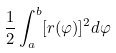<formula> <loc_0><loc_0><loc_500><loc_500>\frac { 1 } { 2 } \int _ { a } ^ { b } [ r ( \varphi ) ] ^ { 2 } d \varphi</formula> 